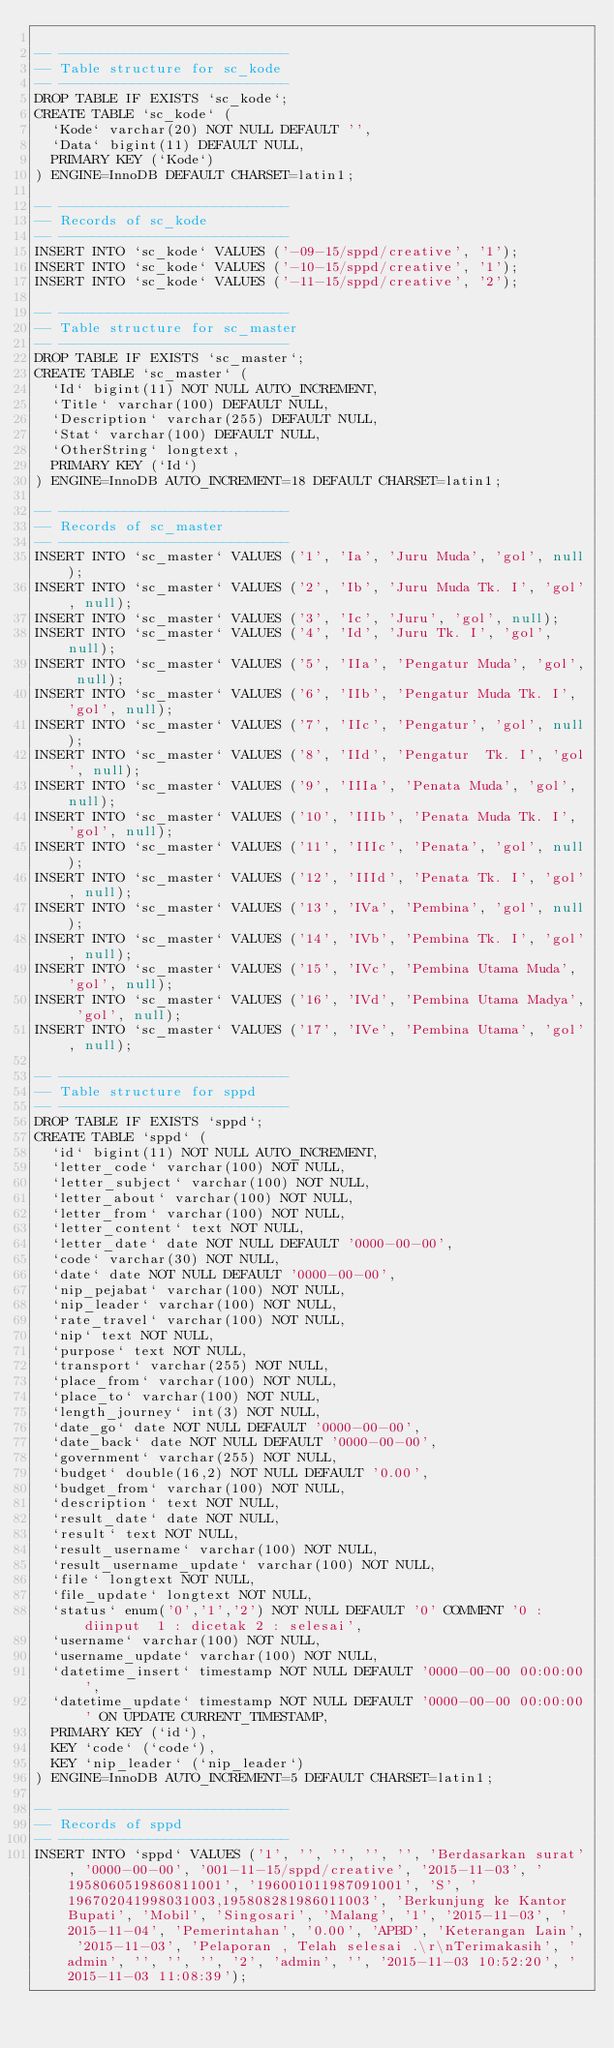<code> <loc_0><loc_0><loc_500><loc_500><_SQL_>
-- ----------------------------
-- Table structure for sc_kode
-- ----------------------------
DROP TABLE IF EXISTS `sc_kode`;
CREATE TABLE `sc_kode` (
  `Kode` varchar(20) NOT NULL DEFAULT '',
  `Data` bigint(11) DEFAULT NULL,
  PRIMARY KEY (`Kode`)
) ENGINE=InnoDB DEFAULT CHARSET=latin1;

-- ----------------------------
-- Records of sc_kode
-- ----------------------------
INSERT INTO `sc_kode` VALUES ('-09-15/sppd/creative', '1');
INSERT INTO `sc_kode` VALUES ('-10-15/sppd/creative', '1');
INSERT INTO `sc_kode` VALUES ('-11-15/sppd/creative', '2');

-- ----------------------------
-- Table structure for sc_master
-- ----------------------------
DROP TABLE IF EXISTS `sc_master`;
CREATE TABLE `sc_master` (
  `Id` bigint(11) NOT NULL AUTO_INCREMENT,
  `Title` varchar(100) DEFAULT NULL,
  `Description` varchar(255) DEFAULT NULL,
  `Stat` varchar(100) DEFAULT NULL,
  `OtherString` longtext,
  PRIMARY KEY (`Id`)
) ENGINE=InnoDB AUTO_INCREMENT=18 DEFAULT CHARSET=latin1;

-- ----------------------------
-- Records of sc_master
-- ----------------------------
INSERT INTO `sc_master` VALUES ('1', 'Ia', 'Juru Muda', 'gol', null);
INSERT INTO `sc_master` VALUES ('2', 'Ib', 'Juru Muda Tk. I', 'gol', null);
INSERT INTO `sc_master` VALUES ('3', 'Ic', 'Juru', 'gol', null);
INSERT INTO `sc_master` VALUES ('4', 'Id', 'Juru Tk. I', 'gol', null);
INSERT INTO `sc_master` VALUES ('5', 'IIa', 'Pengatur Muda', 'gol', null);
INSERT INTO `sc_master` VALUES ('6', 'IIb', 'Pengatur Muda Tk. I', 'gol', null);
INSERT INTO `sc_master` VALUES ('7', 'IIc', 'Pengatur', 'gol', null);
INSERT INTO `sc_master` VALUES ('8', 'IId', 'Pengatur  Tk. I', 'gol', null);
INSERT INTO `sc_master` VALUES ('9', 'IIIa', 'Penata Muda', 'gol', null);
INSERT INTO `sc_master` VALUES ('10', 'IIIb', 'Penata Muda Tk. I', 'gol', null);
INSERT INTO `sc_master` VALUES ('11', 'IIIc', 'Penata', 'gol', null);
INSERT INTO `sc_master` VALUES ('12', 'IIId', 'Penata Tk. I', 'gol', null);
INSERT INTO `sc_master` VALUES ('13', 'IVa', 'Pembina', 'gol', null);
INSERT INTO `sc_master` VALUES ('14', 'IVb', 'Pembina Tk. I', 'gol', null);
INSERT INTO `sc_master` VALUES ('15', 'IVc', 'Pembina Utama Muda', 'gol', null);
INSERT INTO `sc_master` VALUES ('16', 'IVd', 'Pembina Utama Madya', 'gol', null);
INSERT INTO `sc_master` VALUES ('17', 'IVe', 'Pembina Utama', 'gol', null);

-- ----------------------------
-- Table structure for sppd
-- ----------------------------
DROP TABLE IF EXISTS `sppd`;
CREATE TABLE `sppd` (
  `id` bigint(11) NOT NULL AUTO_INCREMENT,
  `letter_code` varchar(100) NOT NULL,
  `letter_subject` varchar(100) NOT NULL,
  `letter_about` varchar(100) NOT NULL,
  `letter_from` varchar(100) NOT NULL,
  `letter_content` text NOT NULL,
  `letter_date` date NOT NULL DEFAULT '0000-00-00',
  `code` varchar(30) NOT NULL,
  `date` date NOT NULL DEFAULT '0000-00-00',
  `nip_pejabat` varchar(100) NOT NULL,
  `nip_leader` varchar(100) NOT NULL,
  `rate_travel` varchar(100) NOT NULL,
  `nip` text NOT NULL,
  `purpose` text NOT NULL,
  `transport` varchar(255) NOT NULL,
  `place_from` varchar(100) NOT NULL,
  `place_to` varchar(100) NOT NULL,
  `length_journey` int(3) NOT NULL,
  `date_go` date NOT NULL DEFAULT '0000-00-00',
  `date_back` date NOT NULL DEFAULT '0000-00-00',
  `government` varchar(255) NOT NULL,
  `budget` double(16,2) NOT NULL DEFAULT '0.00',
  `budget_from` varchar(100) NOT NULL,
  `description` text NOT NULL,
  `result_date` date NOT NULL,
  `result` text NOT NULL,
  `result_username` varchar(100) NOT NULL,
  `result_username_update` varchar(100) NOT NULL,
  `file` longtext NOT NULL,
  `file_update` longtext NOT NULL,
  `status` enum('0','1','2') NOT NULL DEFAULT '0' COMMENT '0 : diinput  1 : dicetak 2 : selesai',
  `username` varchar(100) NOT NULL,
  `username_update` varchar(100) NOT NULL,
  `datetime_insert` timestamp NOT NULL DEFAULT '0000-00-00 00:00:00',
  `datetime_update` timestamp NOT NULL DEFAULT '0000-00-00 00:00:00' ON UPDATE CURRENT_TIMESTAMP,
  PRIMARY KEY (`id`),
  KEY `code` (`code`),
  KEY `nip_leader` (`nip_leader`)
) ENGINE=InnoDB AUTO_INCREMENT=5 DEFAULT CHARSET=latin1;

-- ----------------------------
-- Records of sppd
-- ----------------------------
INSERT INTO `sppd` VALUES ('1', '', '', '', '', 'Berdasarkan surat', '0000-00-00', '001-11-15/sppd/creative', '2015-11-03', '1958060519860811001', '196001011987091001', 'S', '196702041998031003,195808281986011003', 'Berkunjung ke Kantor Bupati', 'Mobil', 'Singosari', 'Malang', '1', '2015-11-03', '2015-11-04', 'Pemerintahan', '0.00', 'APBD', 'Keterangan Lain', '2015-11-03', 'Pelaporan , Telah selesai .\r\nTerimakasih', 'admin', '', '', '', '2', 'admin', '', '2015-11-03 10:52:20', '2015-11-03 11:08:39');</code> 